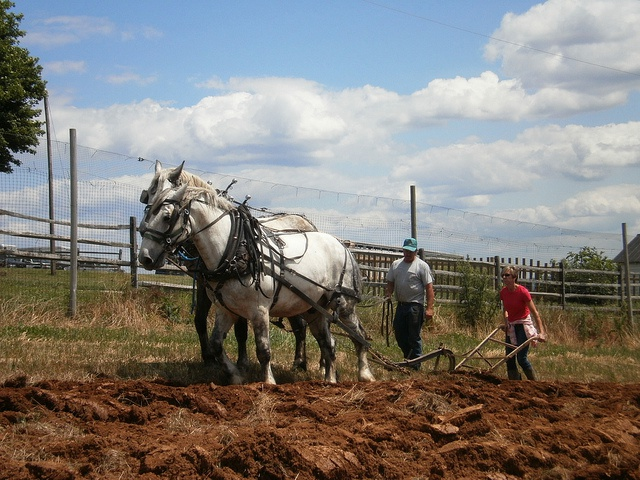Describe the objects in this image and their specific colors. I can see horse in gray, black, ivory, and darkgray tones, horse in gray, black, darkgray, and lightgray tones, people in gray, black, darkgray, and maroon tones, and people in gray, maroon, and black tones in this image. 